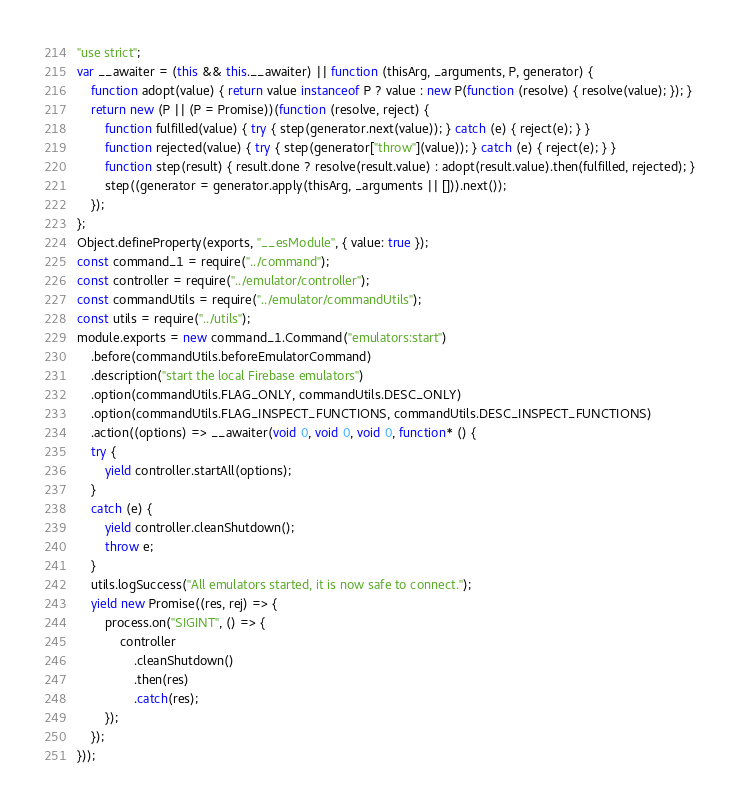Convert code to text. <code><loc_0><loc_0><loc_500><loc_500><_JavaScript_>"use strict";
var __awaiter = (this && this.__awaiter) || function (thisArg, _arguments, P, generator) {
    function adopt(value) { return value instanceof P ? value : new P(function (resolve) { resolve(value); }); }
    return new (P || (P = Promise))(function (resolve, reject) {
        function fulfilled(value) { try { step(generator.next(value)); } catch (e) { reject(e); } }
        function rejected(value) { try { step(generator["throw"](value)); } catch (e) { reject(e); } }
        function step(result) { result.done ? resolve(result.value) : adopt(result.value).then(fulfilled, rejected); }
        step((generator = generator.apply(thisArg, _arguments || [])).next());
    });
};
Object.defineProperty(exports, "__esModule", { value: true });
const command_1 = require("../command");
const controller = require("../emulator/controller");
const commandUtils = require("../emulator/commandUtils");
const utils = require("../utils");
module.exports = new command_1.Command("emulators:start")
    .before(commandUtils.beforeEmulatorCommand)
    .description("start the local Firebase emulators")
    .option(commandUtils.FLAG_ONLY, commandUtils.DESC_ONLY)
    .option(commandUtils.FLAG_INSPECT_FUNCTIONS, commandUtils.DESC_INSPECT_FUNCTIONS)
    .action((options) => __awaiter(void 0, void 0, void 0, function* () {
    try {
        yield controller.startAll(options);
    }
    catch (e) {
        yield controller.cleanShutdown();
        throw e;
    }
    utils.logSuccess("All emulators started, it is now safe to connect.");
    yield new Promise((res, rej) => {
        process.on("SIGINT", () => {
            controller
                .cleanShutdown()
                .then(res)
                .catch(res);
        });
    });
}));
</code> 